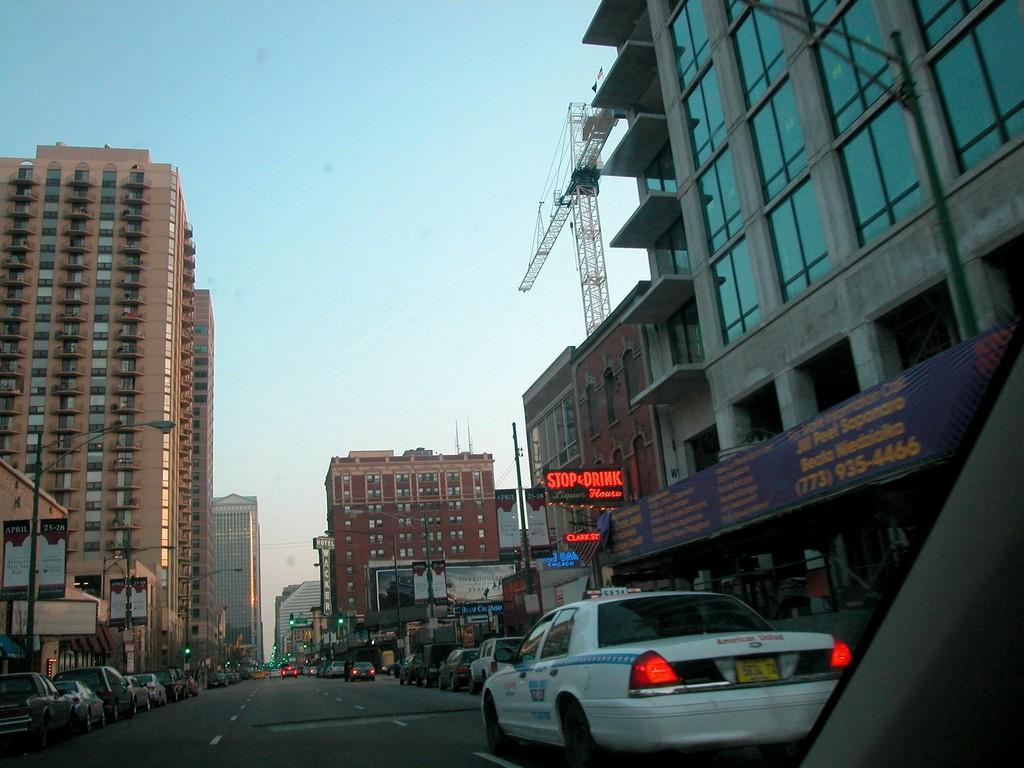<image>
Describe the image concisely. a stop and drink location next to a busy street 